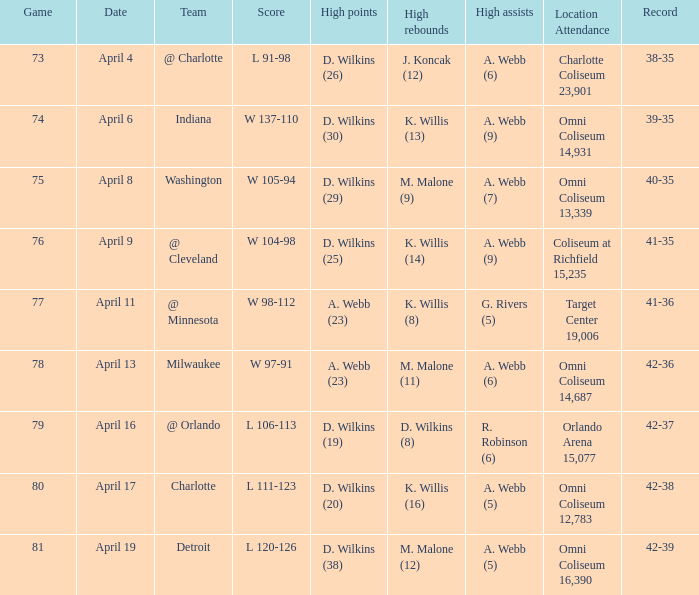Can you parse all the data within this table? {'header': ['Game', 'Date', 'Team', 'Score', 'High points', 'High rebounds', 'High assists', 'Location Attendance', 'Record'], 'rows': [['73', 'April 4', '@ Charlotte', 'L 91-98', 'D. Wilkins (26)', 'J. Koncak (12)', 'A. Webb (6)', 'Charlotte Coliseum 23,901', '38-35'], ['74', 'April 6', 'Indiana', 'W 137-110', 'D. Wilkins (30)', 'K. Willis (13)', 'A. Webb (9)', 'Omni Coliseum 14,931', '39-35'], ['75', 'April 8', 'Washington', 'W 105-94', 'D. Wilkins (29)', 'M. Malone (9)', 'A. Webb (7)', 'Omni Coliseum 13,339', '40-35'], ['76', 'April 9', '@ Cleveland', 'W 104-98', 'D. Wilkins (25)', 'K. Willis (14)', 'A. Webb (9)', 'Coliseum at Richfield 15,235', '41-35'], ['77', 'April 11', '@ Minnesota', 'W 98-112', 'A. Webb (23)', 'K. Willis (8)', 'G. Rivers (5)', 'Target Center 19,006', '41-36'], ['78', 'April 13', 'Milwaukee', 'W 97-91', 'A. Webb (23)', 'M. Malone (11)', 'A. Webb (6)', 'Omni Coliseum 14,687', '42-36'], ['79', 'April 16', '@ Orlando', 'L 106-113', 'D. Wilkins (19)', 'D. Wilkins (8)', 'R. Robinson (6)', 'Orlando Arena 15,077', '42-37'], ['80', 'April 17', 'Charlotte', 'L 111-123', 'D. Wilkins (20)', 'K. Willis (16)', 'A. Webb (5)', 'Omni Coliseum 12,783', '42-38'], ['81', 'April 19', 'Detroit', 'L 120-126', 'D. Wilkins (38)', 'M. Malone (12)', 'A. Webb (5)', 'Omni Coliseum 16,390', '42-39']]} What was the date of the game when g. rivers (5) had the  high assists? April 11. 